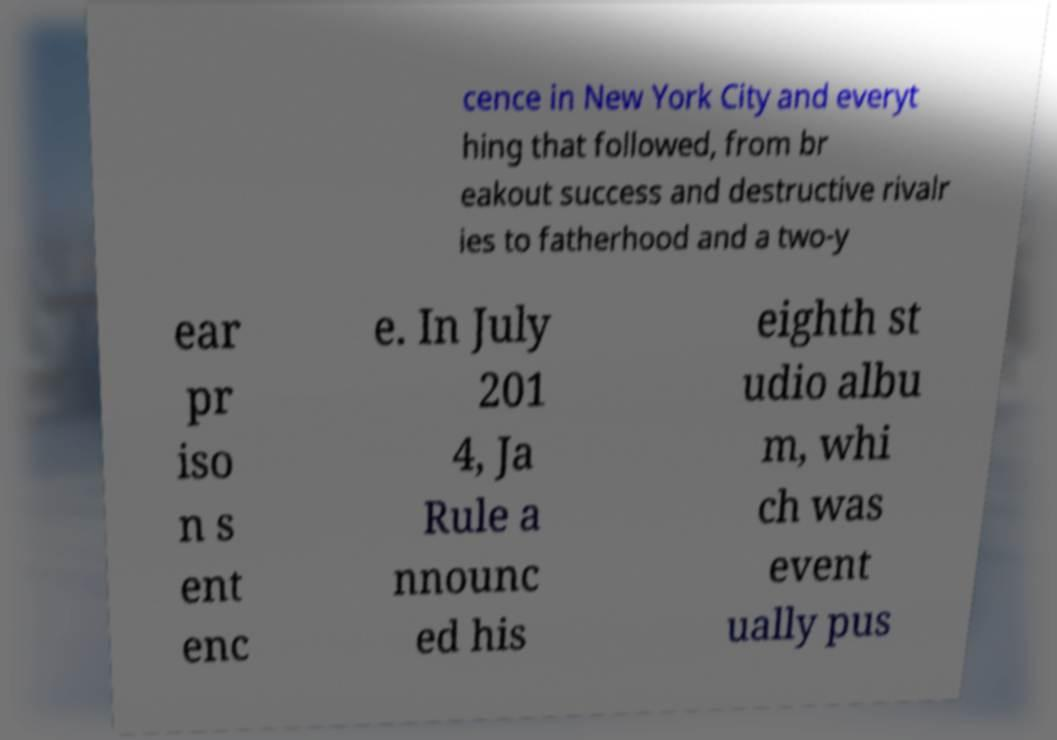I need the written content from this picture converted into text. Can you do that? cence in New York City and everyt hing that followed, from br eakout success and destructive rivalr ies to fatherhood and a two-y ear pr iso n s ent enc e. In July 201 4, Ja Rule a nnounc ed his eighth st udio albu m, whi ch was event ually pus 